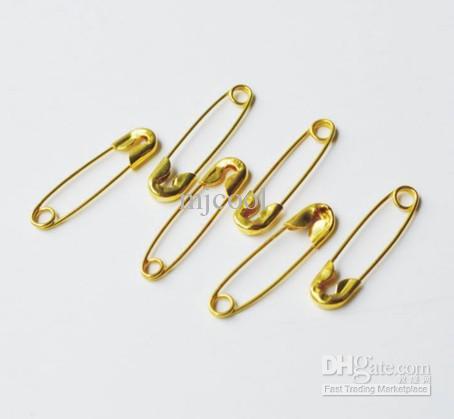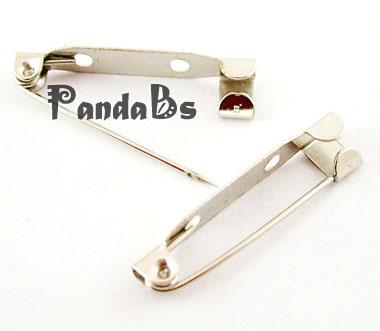The first image is the image on the left, the second image is the image on the right. Evaluate the accuracy of this statement regarding the images: "one of the safety pins is open.". Is it true? Answer yes or no. Yes. 